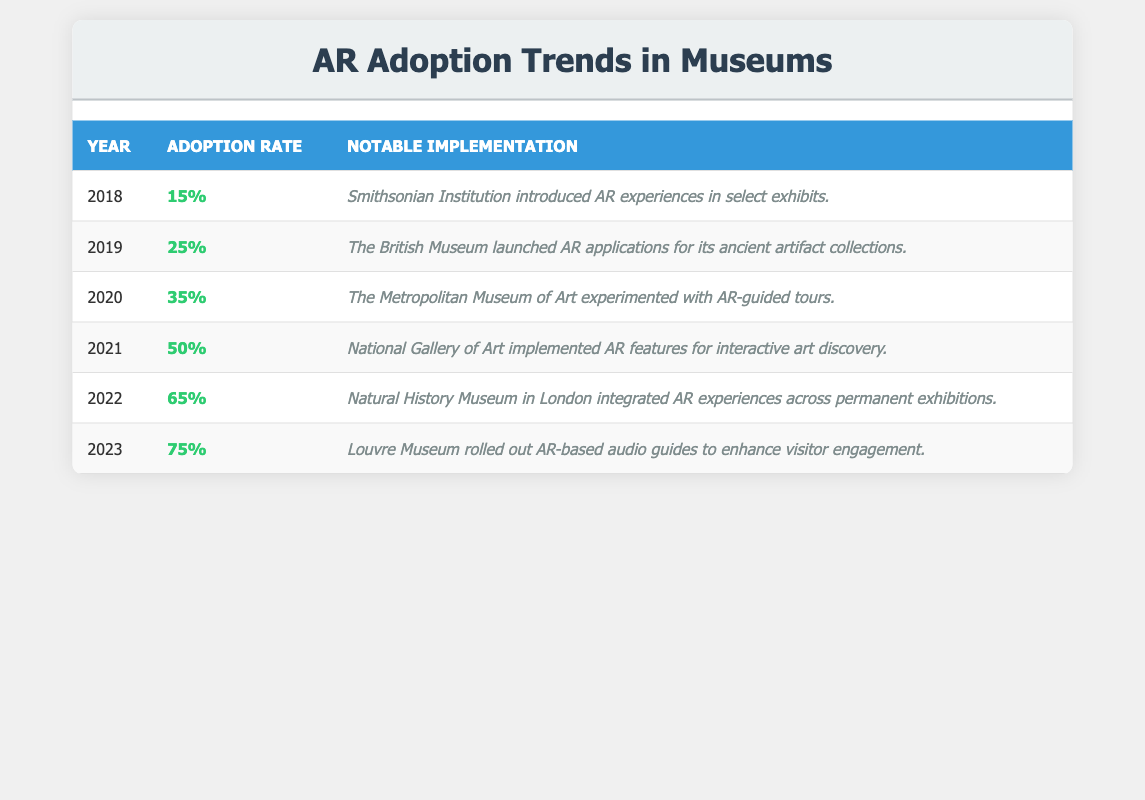What year did the adoption rate first exceed 50%? By reviewing the table, the adoption rate first exceeds 50% in 2021, as the rates are 15%, 25%, 35%, and 50% for the previous years (2018-2020) and jump to 65% in 2022.
Answer: 2021 Which museum implemented AR features for interactive art discovery? The National Gallery of Art implemented AR features for interactive art discovery, as indicated in the notable implementation column for the year 2021.
Answer: National Gallery of Art What was the adoption rate percentage in 2020? The table shows that the adoption rate in 2020 was 35%, as stated under the adoption rate column for that year.
Answer: 35% What was the percentage increase in adoption rate from 2019 to 2020? To find the percentage increase, subtract the 2019 rate (25%) from the 2020 rate (35%), resulting in an increase of 10%. Then, compute the percentage increase as (10/25) * 100 = 40%.
Answer: 40% Which year saw the largest single-year increase in adoption rate? Examining the adoption rates, the largest increase occurs from 2021 to 2022 when the rate jumps from 50% to 65%, an increase of 15 percentage points.
Answer: 2021 to 2022 How many museums are listed as notable implementations in the years presented? The table lists six notable implementations corresponding to each year from 2018 to 2023, confirming that there are six implementations.
Answer: 6 What is the average adoption rate from 2018 to 2023? To calculate the average, add all the adoption rates from 2018 to 2023 (15 + 25 + 35 + 50 + 65 + 75 = 265) and divide by 6, resulting in an average of 265 / 6 = approximately 44.17.
Answer: 44.17 Was there ever a year in which the adoption rate did not increase compared to the previous year? By analyzing the table, all years show an increase in adoption rates over the prior year; thus, there was never a year without an increase.
Answer: No What notable implementation occurred in 2023? The notable implementation for 2023 was the Louvre Museum rolling out AR-based audio guides to enhance visitor engagement, as indicated in that year's entry.
Answer: Louvre Museum AR-based audio guides What is the combined adoption rate for the years 2018 and 2019? To find the combined adoption rate for 2018 and 2019, add the adoption rates for those years (15% + 25% = 40%).
Answer: 40% 